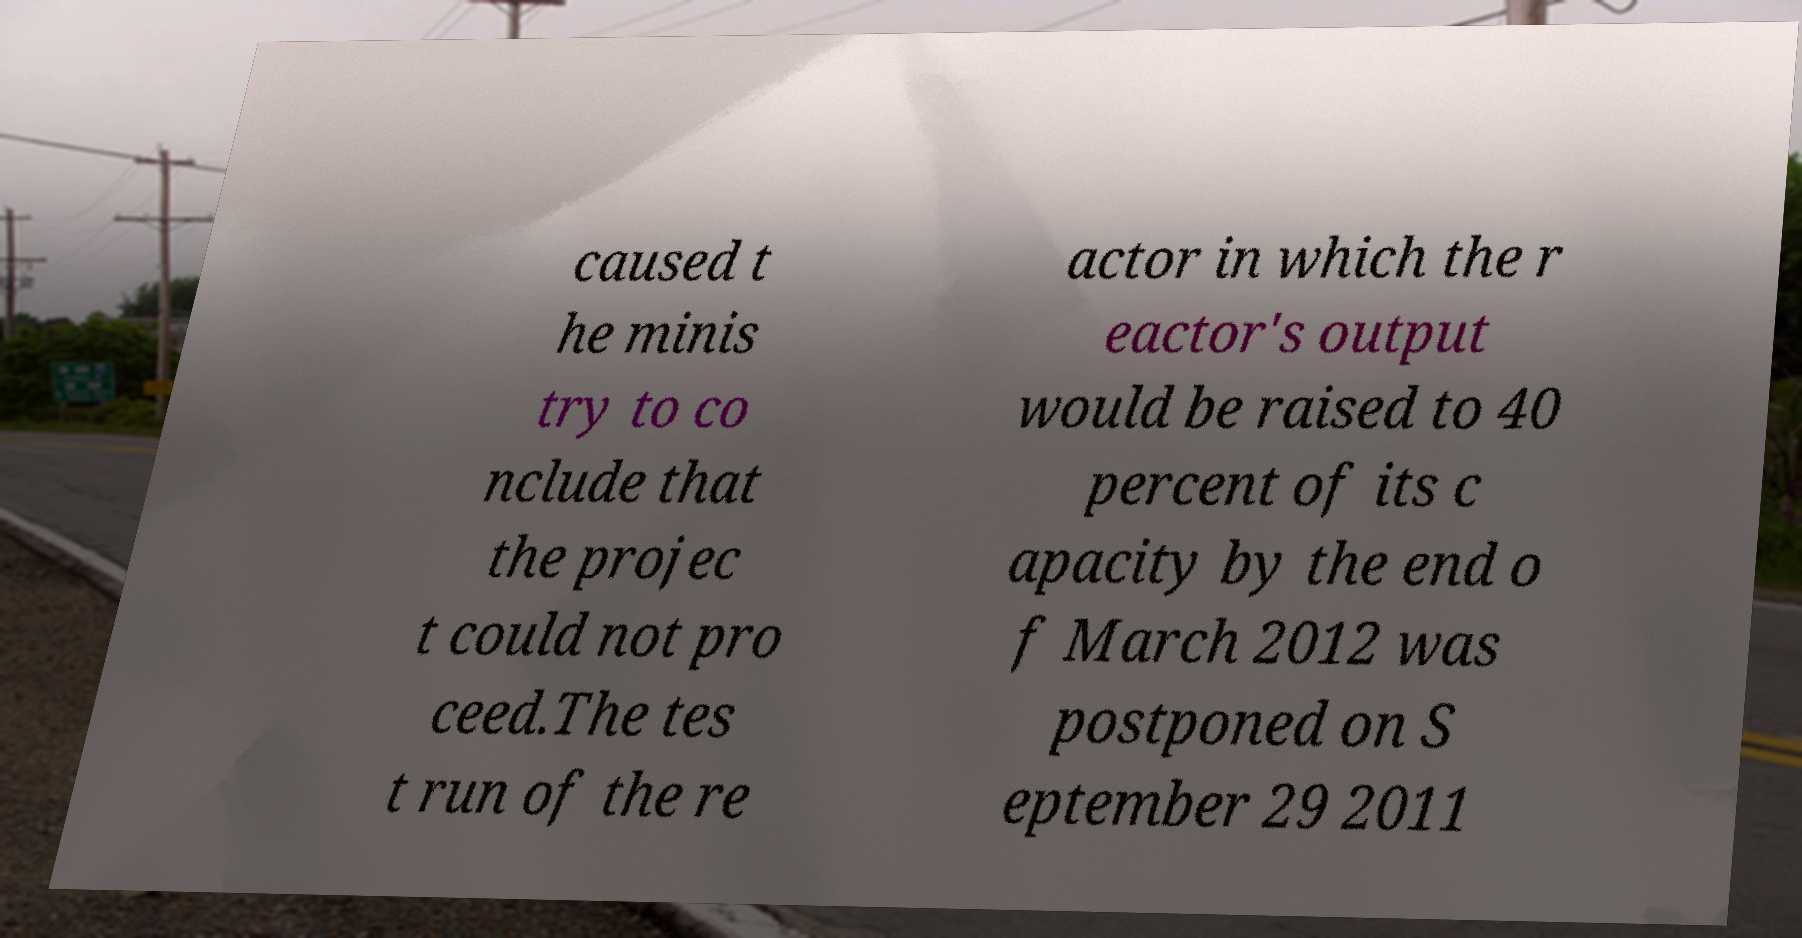Can you accurately transcribe the text from the provided image for me? caused t he minis try to co nclude that the projec t could not pro ceed.The tes t run of the re actor in which the r eactor's output would be raised to 40 percent of its c apacity by the end o f March 2012 was postponed on S eptember 29 2011 